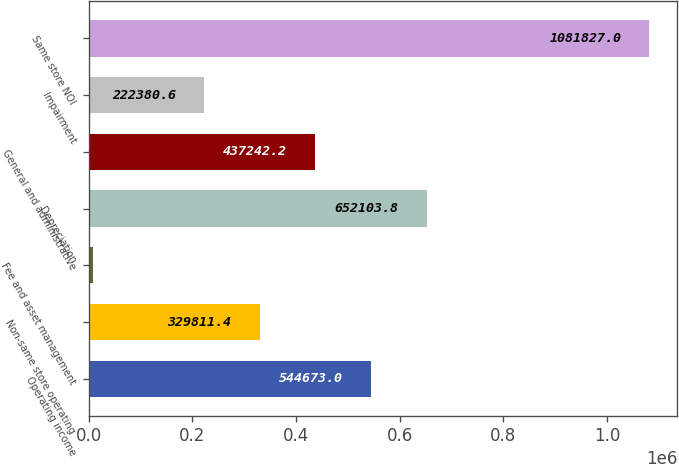Convert chart. <chart><loc_0><loc_0><loc_500><loc_500><bar_chart><fcel>Operating income<fcel>Non-same store operating<fcel>Fee and asset management<fcel>Depreciation<fcel>General and administrative<fcel>Impairment<fcel>Same store NOI<nl><fcel>544673<fcel>329811<fcel>7519<fcel>652104<fcel>437242<fcel>222381<fcel>1.08183e+06<nl></chart> 